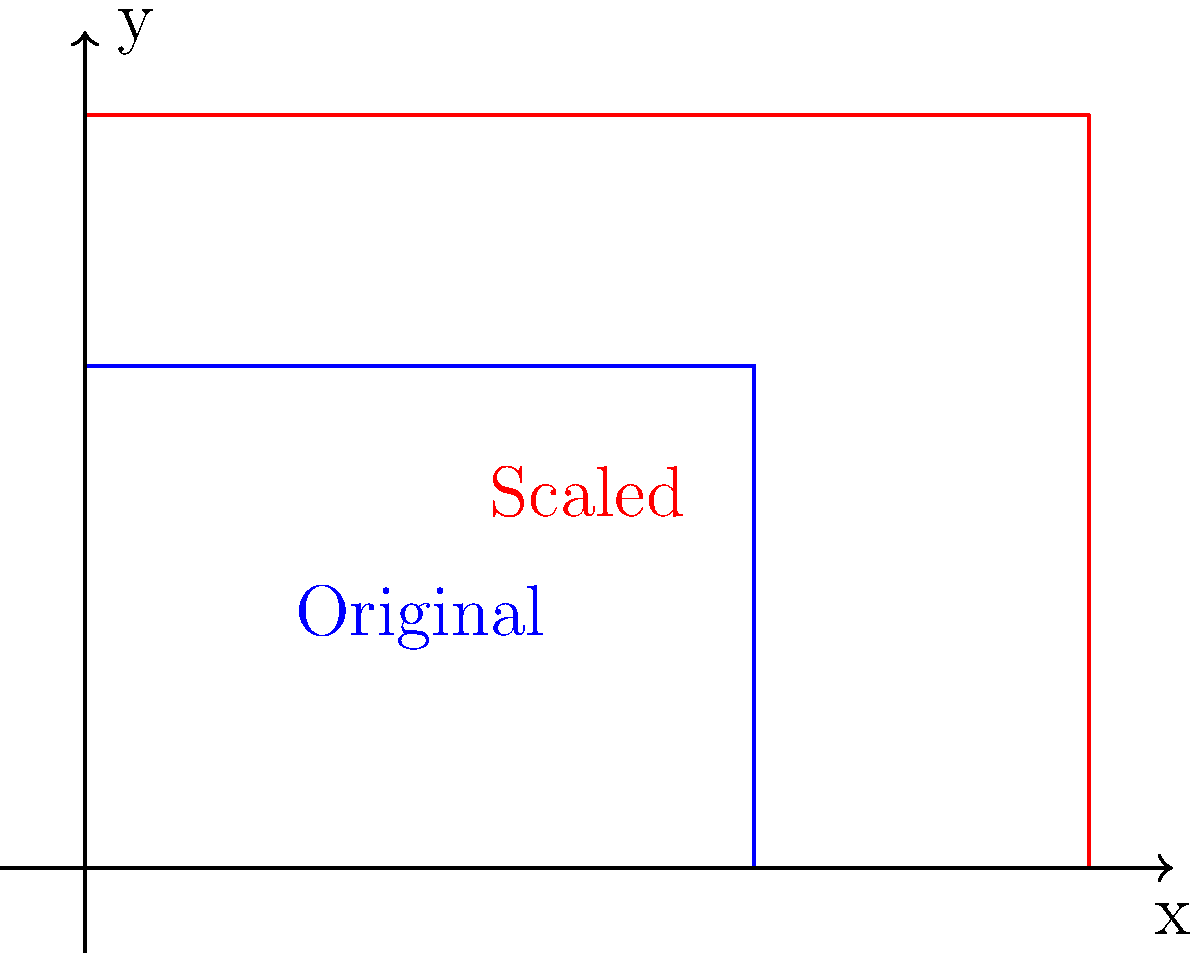A community garden layout is represented by a rectangle measuring 4 units wide and 3 units long. To accommodate a larger lot, the layout needs to be scaled up. If the width of the new layout is 6 units, what will be the length of the scaled garden to maintain the same proportions? To solve this problem, we need to use the concept of scaling in transformational geometry. Here's a step-by-step explanation:

1. Identify the original dimensions:
   - Original width: $w_1 = 4$ units
   - Original length: $l_1 = 3$ units

2. Identify the new width:
   - New width: $w_2 = 6$ units

3. Calculate the scale factor:
   - Scale factor = New width ÷ Original width
   - $SF = \frac{w_2}{w_1} = \frac{6}{4} = 1.5$

4. Apply the scale factor to the original length:
   - New length = Original length × Scale factor
   - $l_2 = l_1 \times SF = 3 \times 1.5 = 4.5$ units

The scaling transformation preserves the proportions of the original figure. This means that the ratio of length to width remains constant:

$$\frac{l_1}{w_1} = \frac{l_2}{w_2}$$

We can verify this:
$$\frac{3}{4} = \frac{4.5}{6} = 0.75$$

Therefore, the length of the scaled garden layout will be 4.5 units.
Answer: 4.5 units 